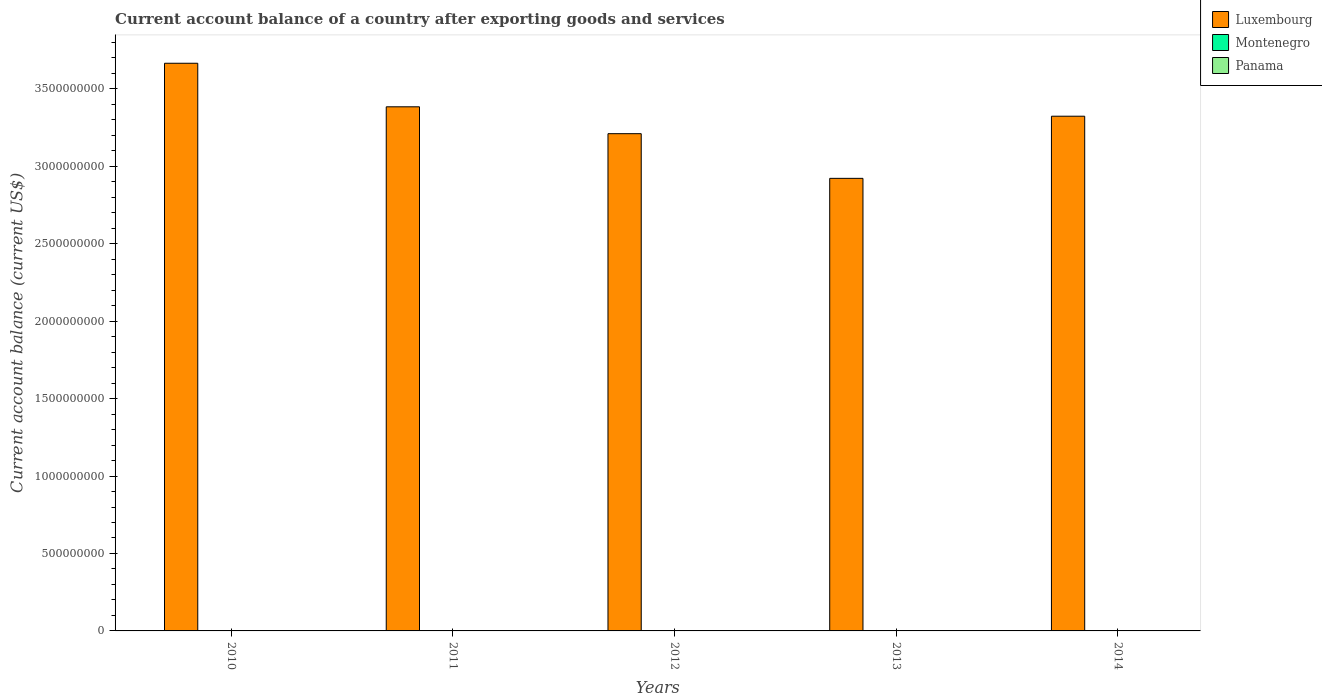How many bars are there on the 1st tick from the right?
Your response must be concise. 1. Across all years, what is the maximum account balance in Luxembourg?
Your answer should be very brief. 3.66e+09. In which year was the account balance in Luxembourg maximum?
Your answer should be compact. 2010. What is the difference between the account balance in Luxembourg in 2010 and that in 2013?
Provide a short and direct response. 7.43e+08. What is the difference between the account balance in Luxembourg in 2010 and the account balance in Panama in 2013?
Your answer should be compact. 3.66e+09. In how many years, is the account balance in Luxembourg greater than 2400000000 US$?
Make the answer very short. 5. What is the difference between the highest and the lowest account balance in Luxembourg?
Ensure brevity in your answer.  7.43e+08. In how many years, is the account balance in Luxembourg greater than the average account balance in Luxembourg taken over all years?
Offer a terse response. 3. Is it the case that in every year, the sum of the account balance in Montenegro and account balance in Luxembourg is greater than the account balance in Panama?
Offer a terse response. Yes. How many bars are there?
Offer a terse response. 5. How many years are there in the graph?
Your answer should be very brief. 5. Are the values on the major ticks of Y-axis written in scientific E-notation?
Keep it short and to the point. No. Does the graph contain grids?
Ensure brevity in your answer.  No. Where does the legend appear in the graph?
Provide a succinct answer. Top right. How many legend labels are there?
Your answer should be compact. 3. What is the title of the graph?
Ensure brevity in your answer.  Current account balance of a country after exporting goods and services. What is the label or title of the X-axis?
Provide a succinct answer. Years. What is the label or title of the Y-axis?
Give a very brief answer. Current account balance (current US$). What is the Current account balance (current US$) of Luxembourg in 2010?
Make the answer very short. 3.66e+09. What is the Current account balance (current US$) of Montenegro in 2010?
Give a very brief answer. 0. What is the Current account balance (current US$) in Panama in 2010?
Offer a very short reply. 0. What is the Current account balance (current US$) in Luxembourg in 2011?
Keep it short and to the point. 3.38e+09. What is the Current account balance (current US$) in Luxembourg in 2012?
Give a very brief answer. 3.21e+09. What is the Current account balance (current US$) of Montenegro in 2012?
Make the answer very short. 0. What is the Current account balance (current US$) of Panama in 2012?
Your answer should be compact. 0. What is the Current account balance (current US$) of Luxembourg in 2013?
Keep it short and to the point. 2.92e+09. What is the Current account balance (current US$) of Montenegro in 2013?
Ensure brevity in your answer.  0. What is the Current account balance (current US$) of Panama in 2013?
Give a very brief answer. 0. What is the Current account balance (current US$) of Luxembourg in 2014?
Your answer should be compact. 3.32e+09. Across all years, what is the maximum Current account balance (current US$) of Luxembourg?
Provide a short and direct response. 3.66e+09. Across all years, what is the minimum Current account balance (current US$) of Luxembourg?
Give a very brief answer. 2.92e+09. What is the total Current account balance (current US$) of Luxembourg in the graph?
Your response must be concise. 1.65e+1. What is the total Current account balance (current US$) in Montenegro in the graph?
Give a very brief answer. 0. What is the total Current account balance (current US$) of Panama in the graph?
Ensure brevity in your answer.  0. What is the difference between the Current account balance (current US$) in Luxembourg in 2010 and that in 2011?
Ensure brevity in your answer.  2.81e+08. What is the difference between the Current account balance (current US$) in Luxembourg in 2010 and that in 2012?
Keep it short and to the point. 4.55e+08. What is the difference between the Current account balance (current US$) in Luxembourg in 2010 and that in 2013?
Keep it short and to the point. 7.43e+08. What is the difference between the Current account balance (current US$) in Luxembourg in 2010 and that in 2014?
Give a very brief answer. 3.42e+08. What is the difference between the Current account balance (current US$) of Luxembourg in 2011 and that in 2012?
Provide a short and direct response. 1.73e+08. What is the difference between the Current account balance (current US$) in Luxembourg in 2011 and that in 2013?
Your response must be concise. 4.62e+08. What is the difference between the Current account balance (current US$) in Luxembourg in 2011 and that in 2014?
Keep it short and to the point. 6.07e+07. What is the difference between the Current account balance (current US$) in Luxembourg in 2012 and that in 2013?
Make the answer very short. 2.88e+08. What is the difference between the Current account balance (current US$) in Luxembourg in 2012 and that in 2014?
Your answer should be very brief. -1.13e+08. What is the difference between the Current account balance (current US$) of Luxembourg in 2013 and that in 2014?
Make the answer very short. -4.01e+08. What is the average Current account balance (current US$) of Luxembourg per year?
Provide a short and direct response. 3.30e+09. What is the average Current account balance (current US$) in Montenegro per year?
Your answer should be very brief. 0. What is the average Current account balance (current US$) in Panama per year?
Your response must be concise. 0. What is the ratio of the Current account balance (current US$) of Luxembourg in 2010 to that in 2011?
Your answer should be very brief. 1.08. What is the ratio of the Current account balance (current US$) of Luxembourg in 2010 to that in 2012?
Offer a very short reply. 1.14. What is the ratio of the Current account balance (current US$) in Luxembourg in 2010 to that in 2013?
Your response must be concise. 1.25. What is the ratio of the Current account balance (current US$) in Luxembourg in 2010 to that in 2014?
Make the answer very short. 1.1. What is the ratio of the Current account balance (current US$) in Luxembourg in 2011 to that in 2012?
Your response must be concise. 1.05. What is the ratio of the Current account balance (current US$) in Luxembourg in 2011 to that in 2013?
Make the answer very short. 1.16. What is the ratio of the Current account balance (current US$) of Luxembourg in 2011 to that in 2014?
Provide a short and direct response. 1.02. What is the ratio of the Current account balance (current US$) in Luxembourg in 2012 to that in 2013?
Your answer should be compact. 1.1. What is the ratio of the Current account balance (current US$) in Luxembourg in 2012 to that in 2014?
Provide a succinct answer. 0.97. What is the ratio of the Current account balance (current US$) of Luxembourg in 2013 to that in 2014?
Give a very brief answer. 0.88. What is the difference between the highest and the second highest Current account balance (current US$) of Luxembourg?
Ensure brevity in your answer.  2.81e+08. What is the difference between the highest and the lowest Current account balance (current US$) in Luxembourg?
Give a very brief answer. 7.43e+08. 